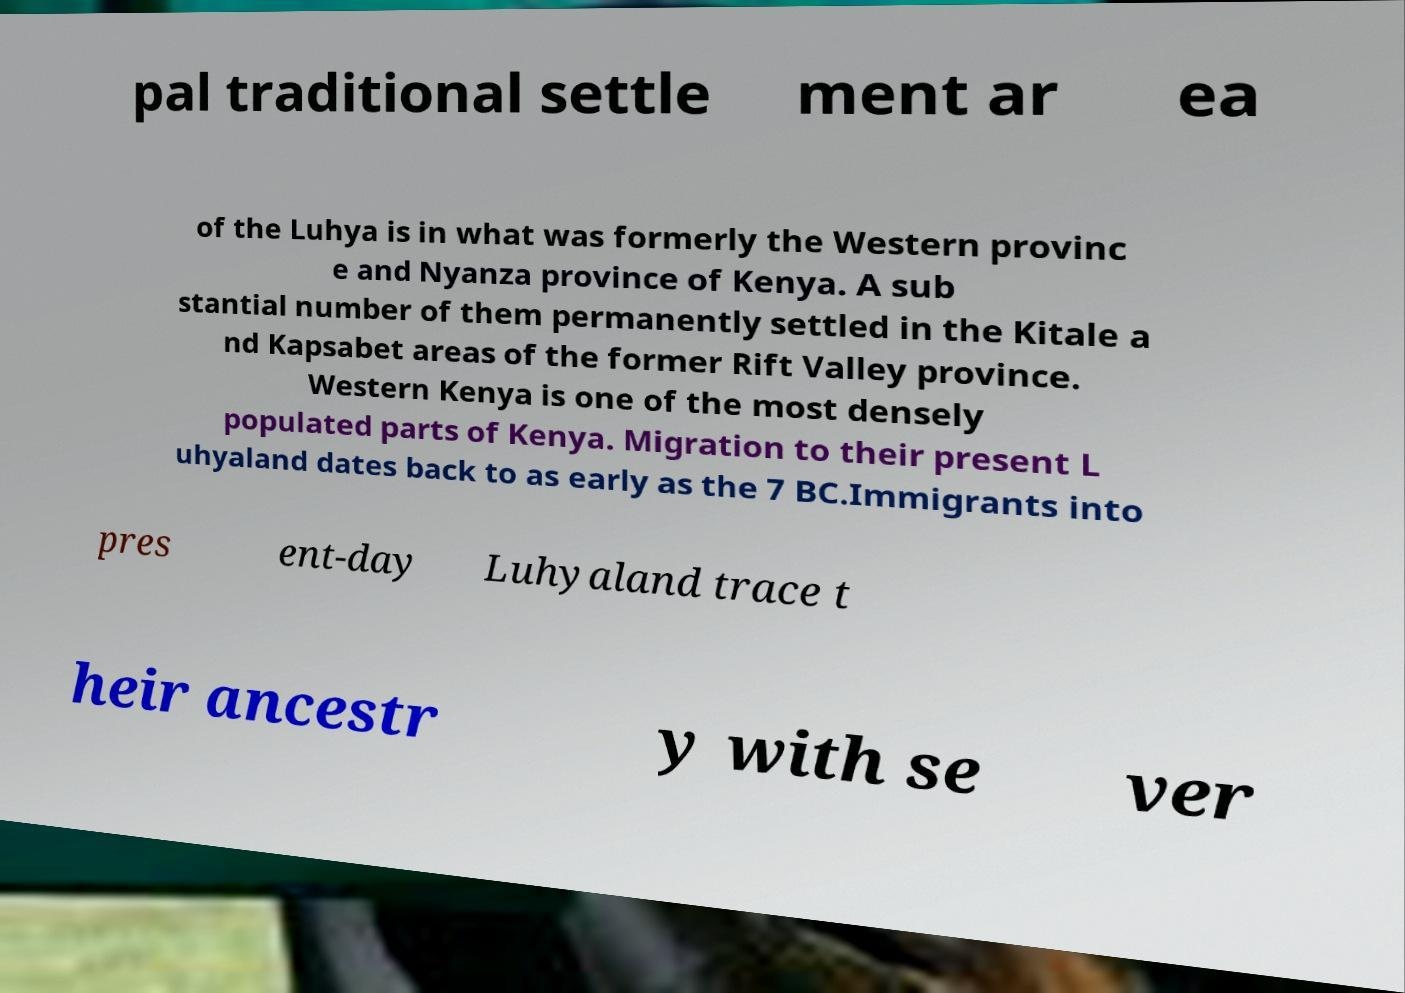I need the written content from this picture converted into text. Can you do that? pal traditional settle ment ar ea of the Luhya is in what was formerly the Western provinc e and Nyanza province of Kenya. A sub stantial number of them permanently settled in the Kitale a nd Kapsabet areas of the former Rift Valley province. Western Kenya is one of the most densely populated parts of Kenya. Migration to their present L uhyaland dates back to as early as the 7 BC.Immigrants into pres ent-day Luhyaland trace t heir ancestr y with se ver 